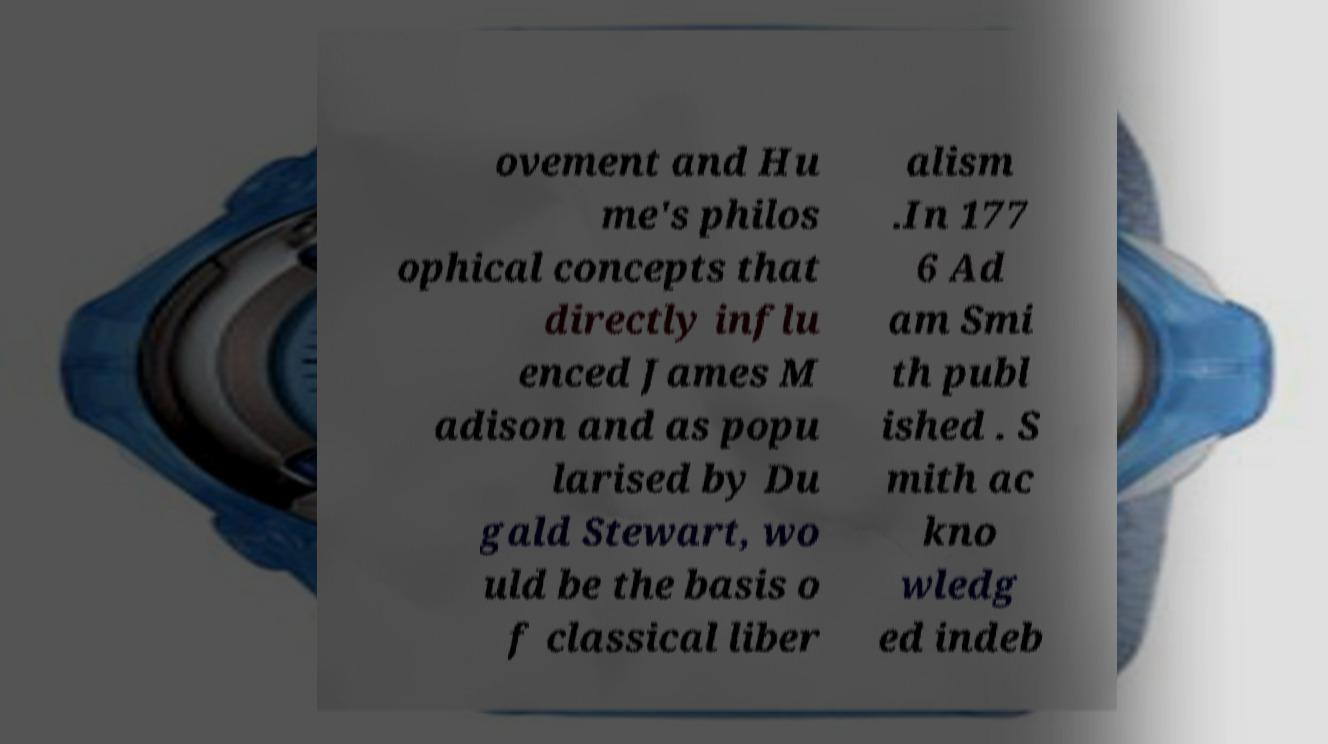Can you accurately transcribe the text from the provided image for me? ovement and Hu me's philos ophical concepts that directly influ enced James M adison and as popu larised by Du gald Stewart, wo uld be the basis o f classical liber alism .In 177 6 Ad am Smi th publ ished . S mith ac kno wledg ed indeb 